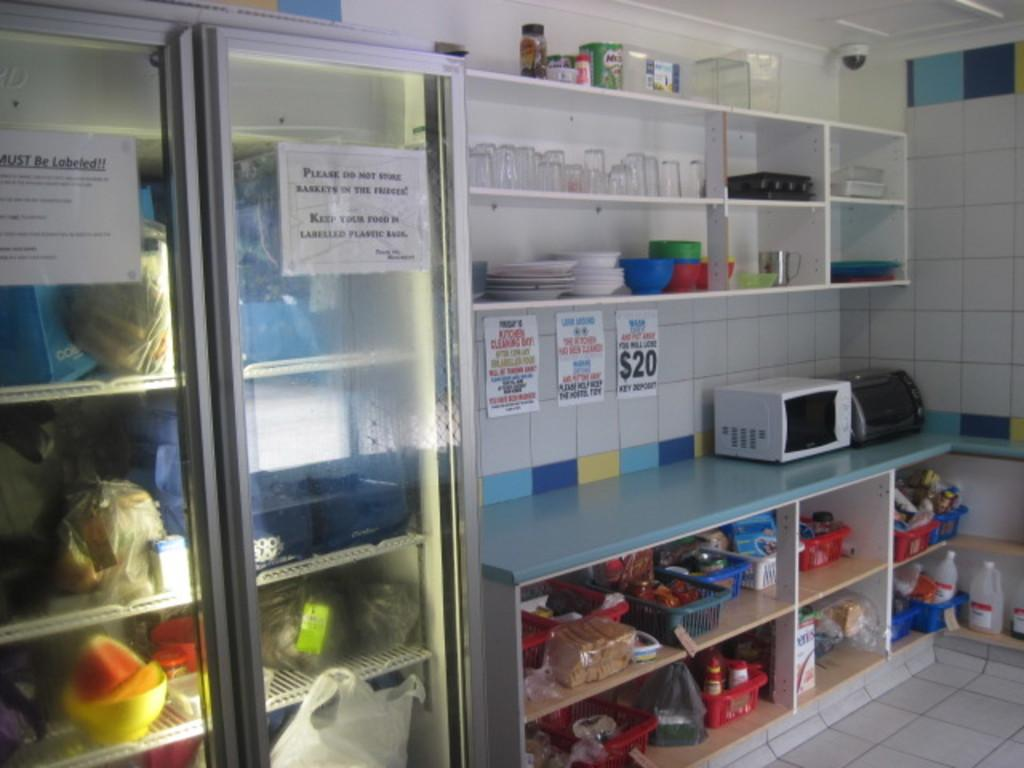<image>
Describe the image concisely. A sign for a $20 key deposit is on the wall behind where a microwave sits. 